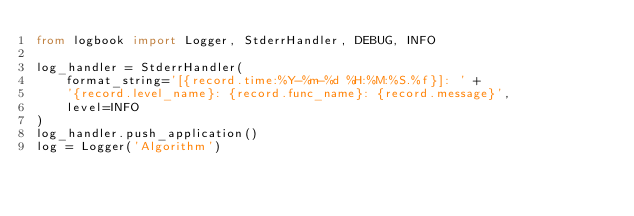Convert code to text. <code><loc_0><loc_0><loc_500><loc_500><_Python_>from logbook import Logger, StderrHandler, DEBUG, INFO

log_handler = StderrHandler(
    format_string='[{record.time:%Y-%m-%d %H:%M:%S.%f}]: ' +
    '{record.level_name}: {record.func_name}: {record.message}',
    level=INFO
)
log_handler.push_application()
log = Logger('Algorithm')
</code> 